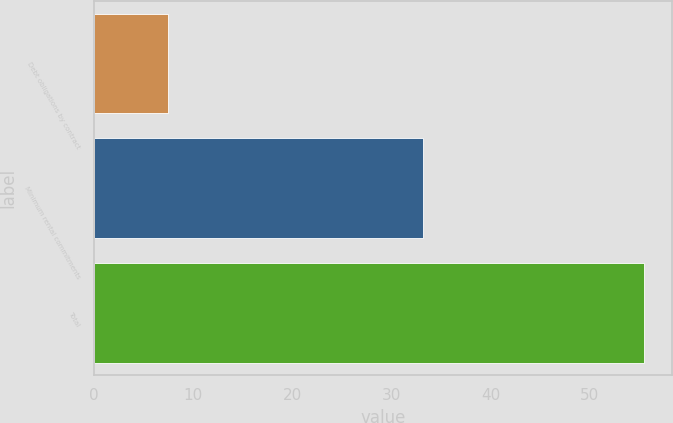<chart> <loc_0><loc_0><loc_500><loc_500><bar_chart><fcel>Debt obligations by contract<fcel>Minimum rental commitments<fcel>Total<nl><fcel>7.5<fcel>33.2<fcel>55.5<nl></chart> 